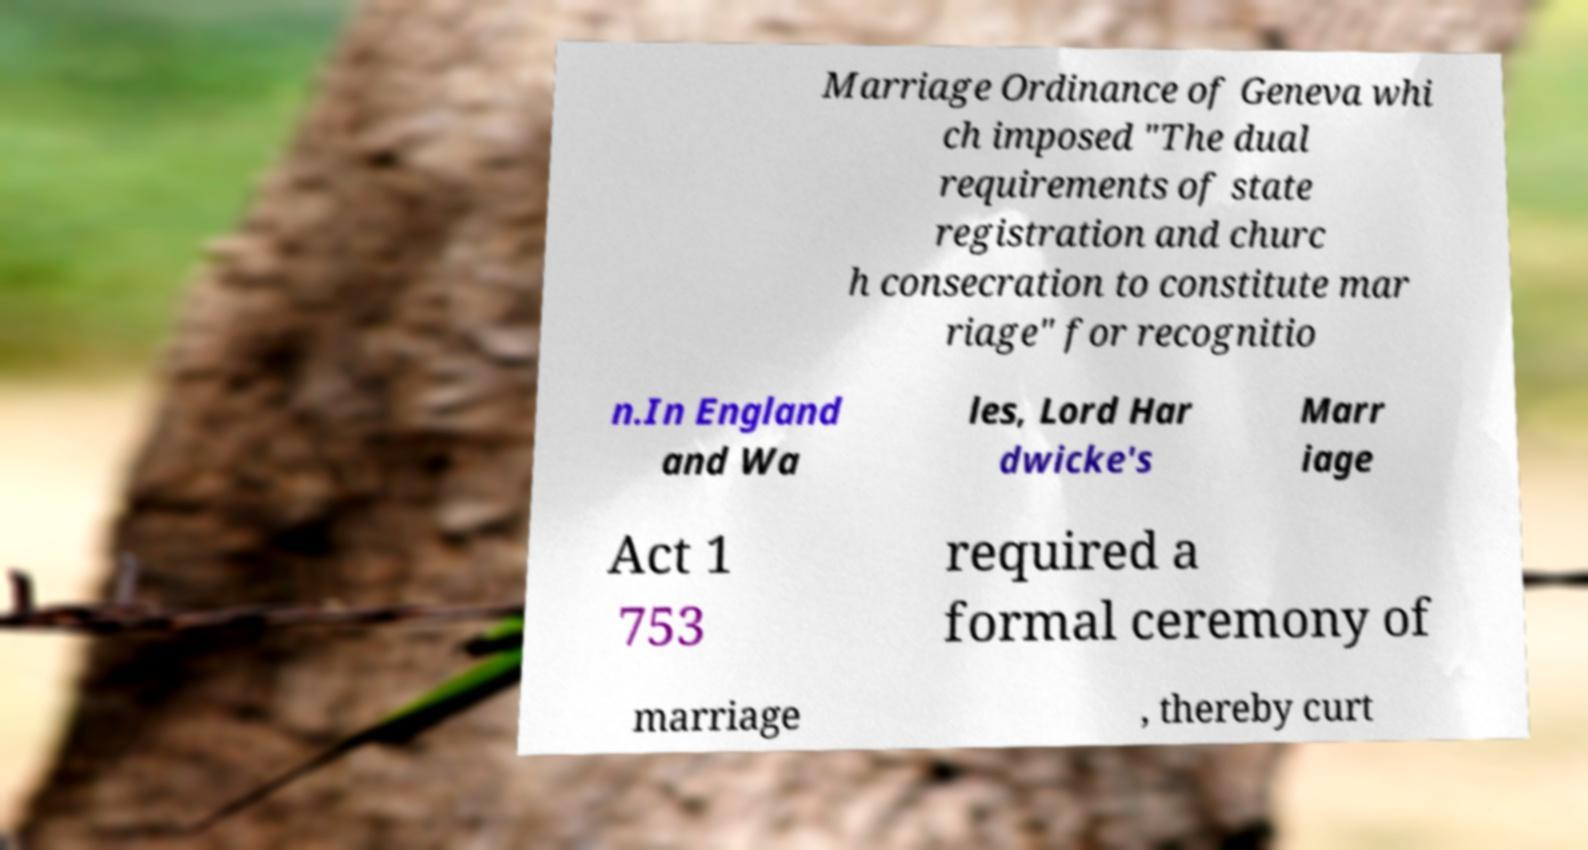Please identify and transcribe the text found in this image. Marriage Ordinance of Geneva whi ch imposed "The dual requirements of state registration and churc h consecration to constitute mar riage" for recognitio n.In England and Wa les, Lord Har dwicke's Marr iage Act 1 753 required a formal ceremony of marriage , thereby curt 